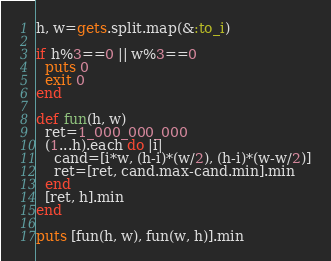Convert code to text. <code><loc_0><loc_0><loc_500><loc_500><_Ruby_>h, w=gets.split.map(&:to_i)

if h%3==0 || w%3==0
  puts 0
  exit 0
end

def fun(h, w)
  ret=1_000_000_000
  (1...h).each do |i|
    cand=[i*w, (h-i)*(w/2), (h-i)*(w-w/2)]
    ret=[ret, cand.max-cand.min].min
  end
  [ret, h].min
end

puts [fun(h, w), fun(w, h)].min</code> 